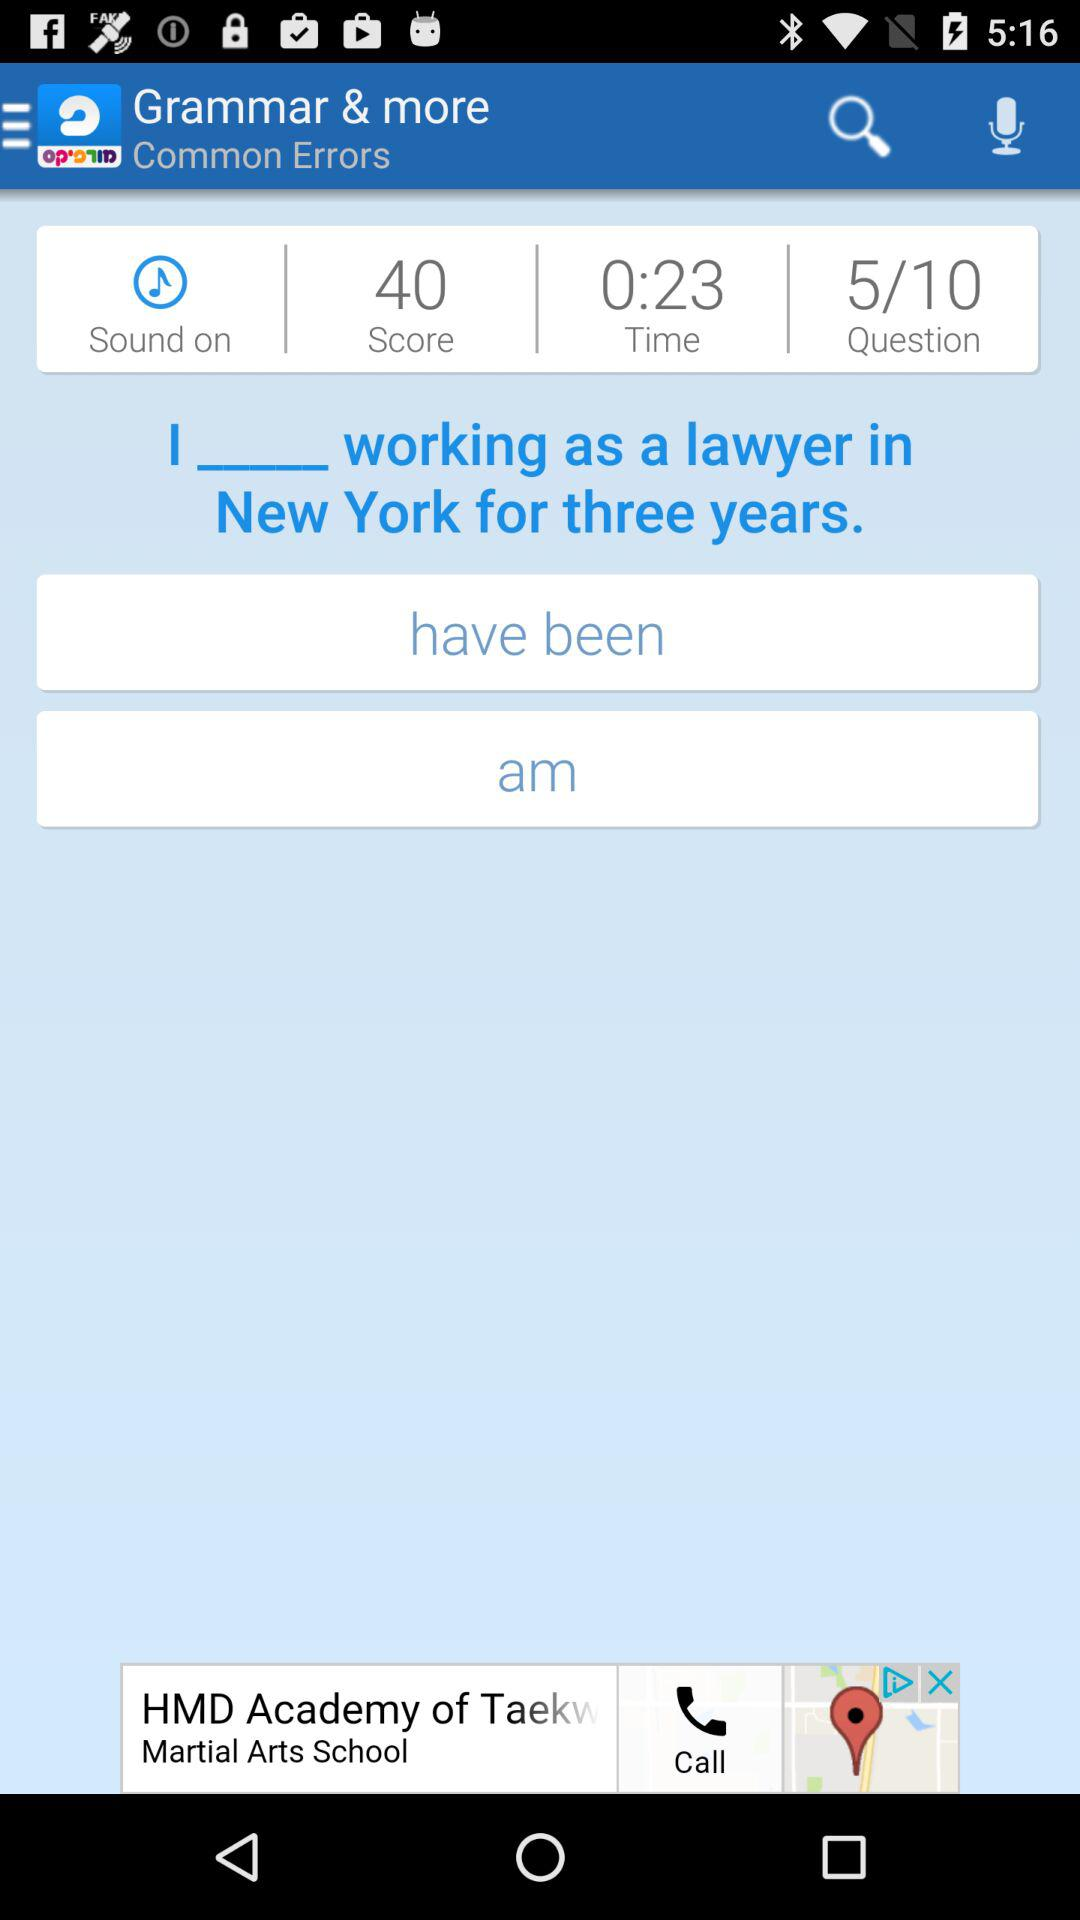What is the available score? The available score is 40. 